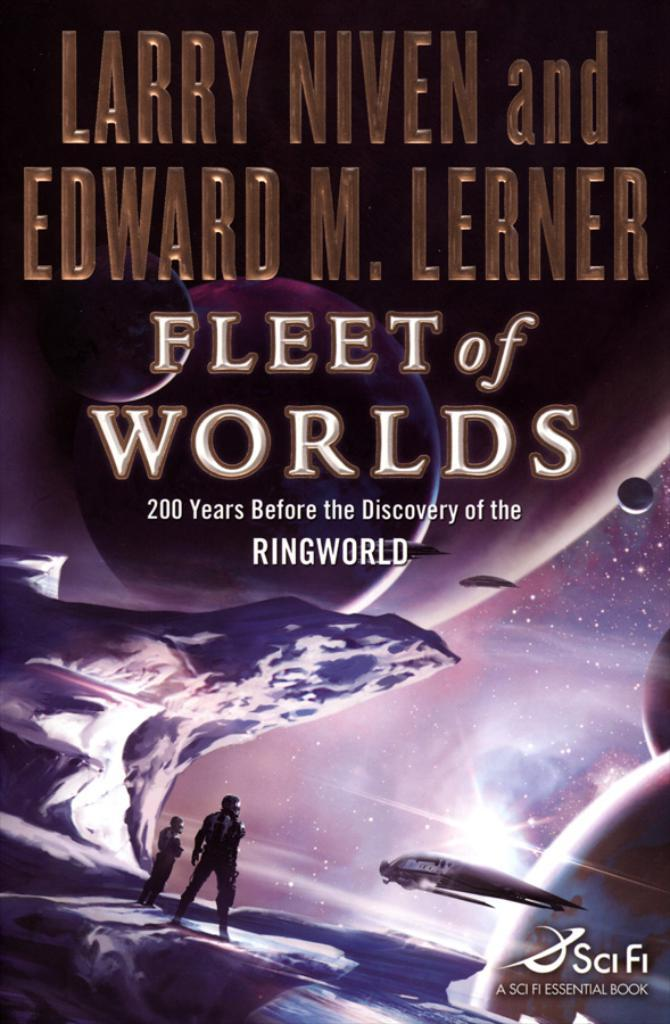<image>
Offer a succinct explanation of the picture presented. Fleet of Worlds book by Larry Niven with a airplane and two people on the cover. 